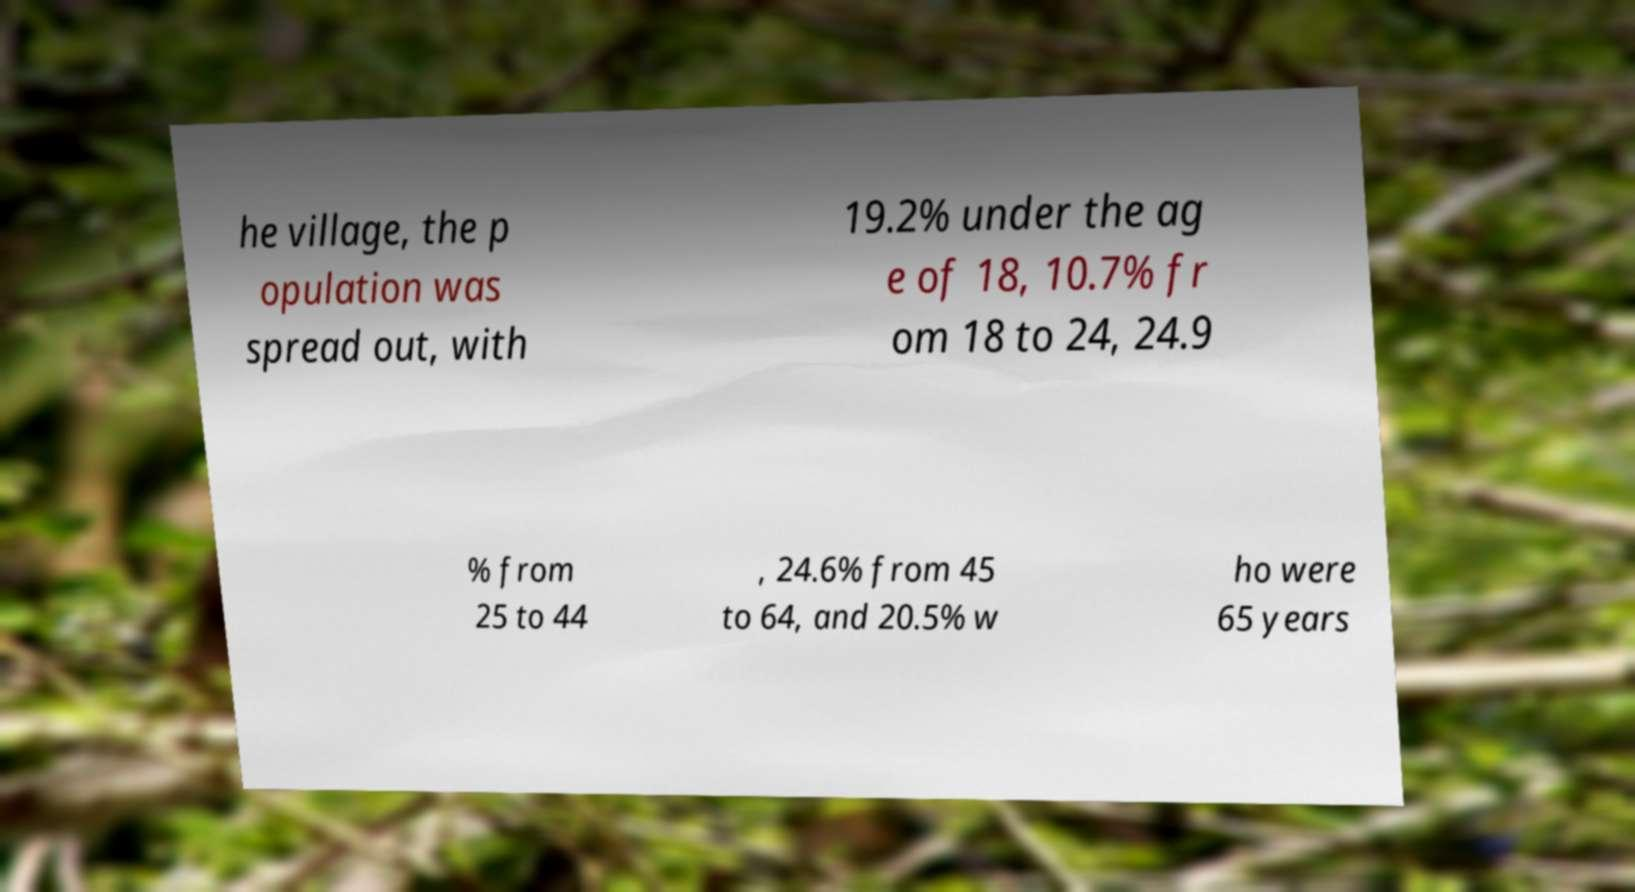Can you accurately transcribe the text from the provided image for me? he village, the p opulation was spread out, with 19.2% under the ag e of 18, 10.7% fr om 18 to 24, 24.9 % from 25 to 44 , 24.6% from 45 to 64, and 20.5% w ho were 65 years 